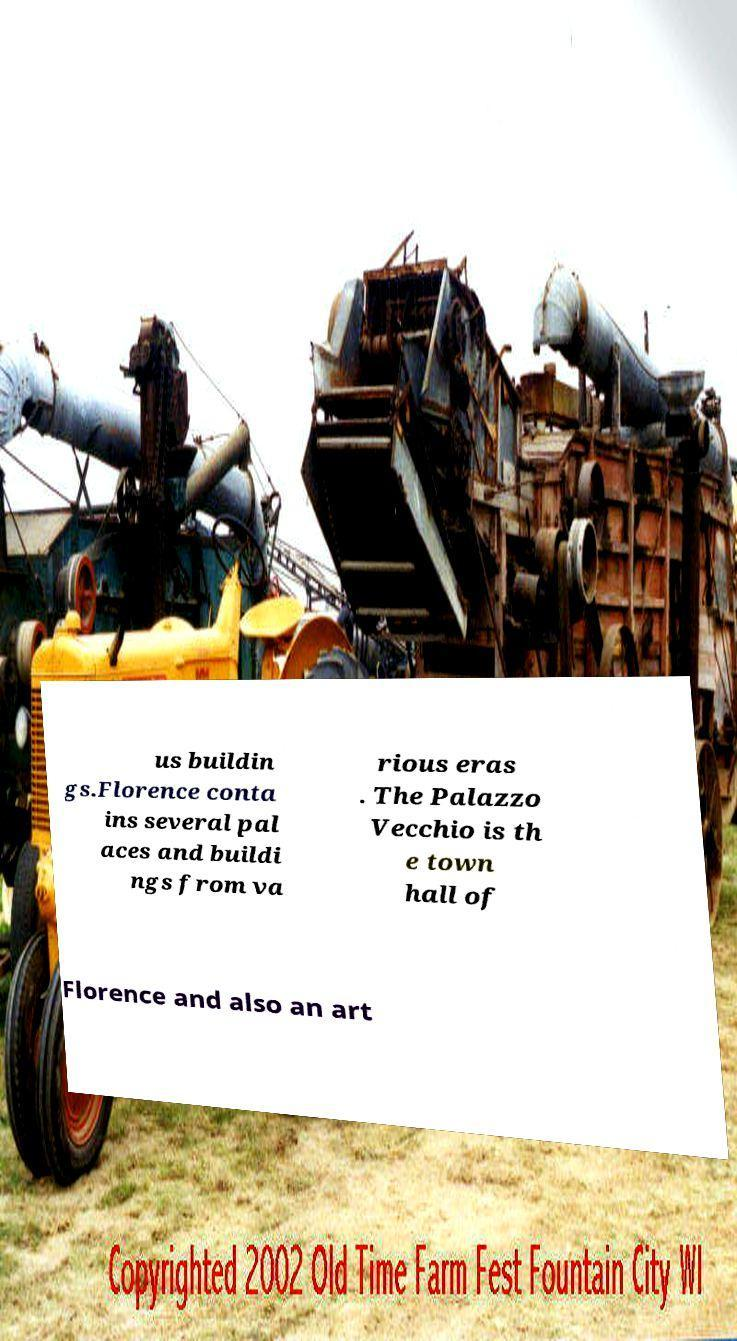Please identify and transcribe the text found in this image. us buildin gs.Florence conta ins several pal aces and buildi ngs from va rious eras . The Palazzo Vecchio is th e town hall of Florence and also an art 